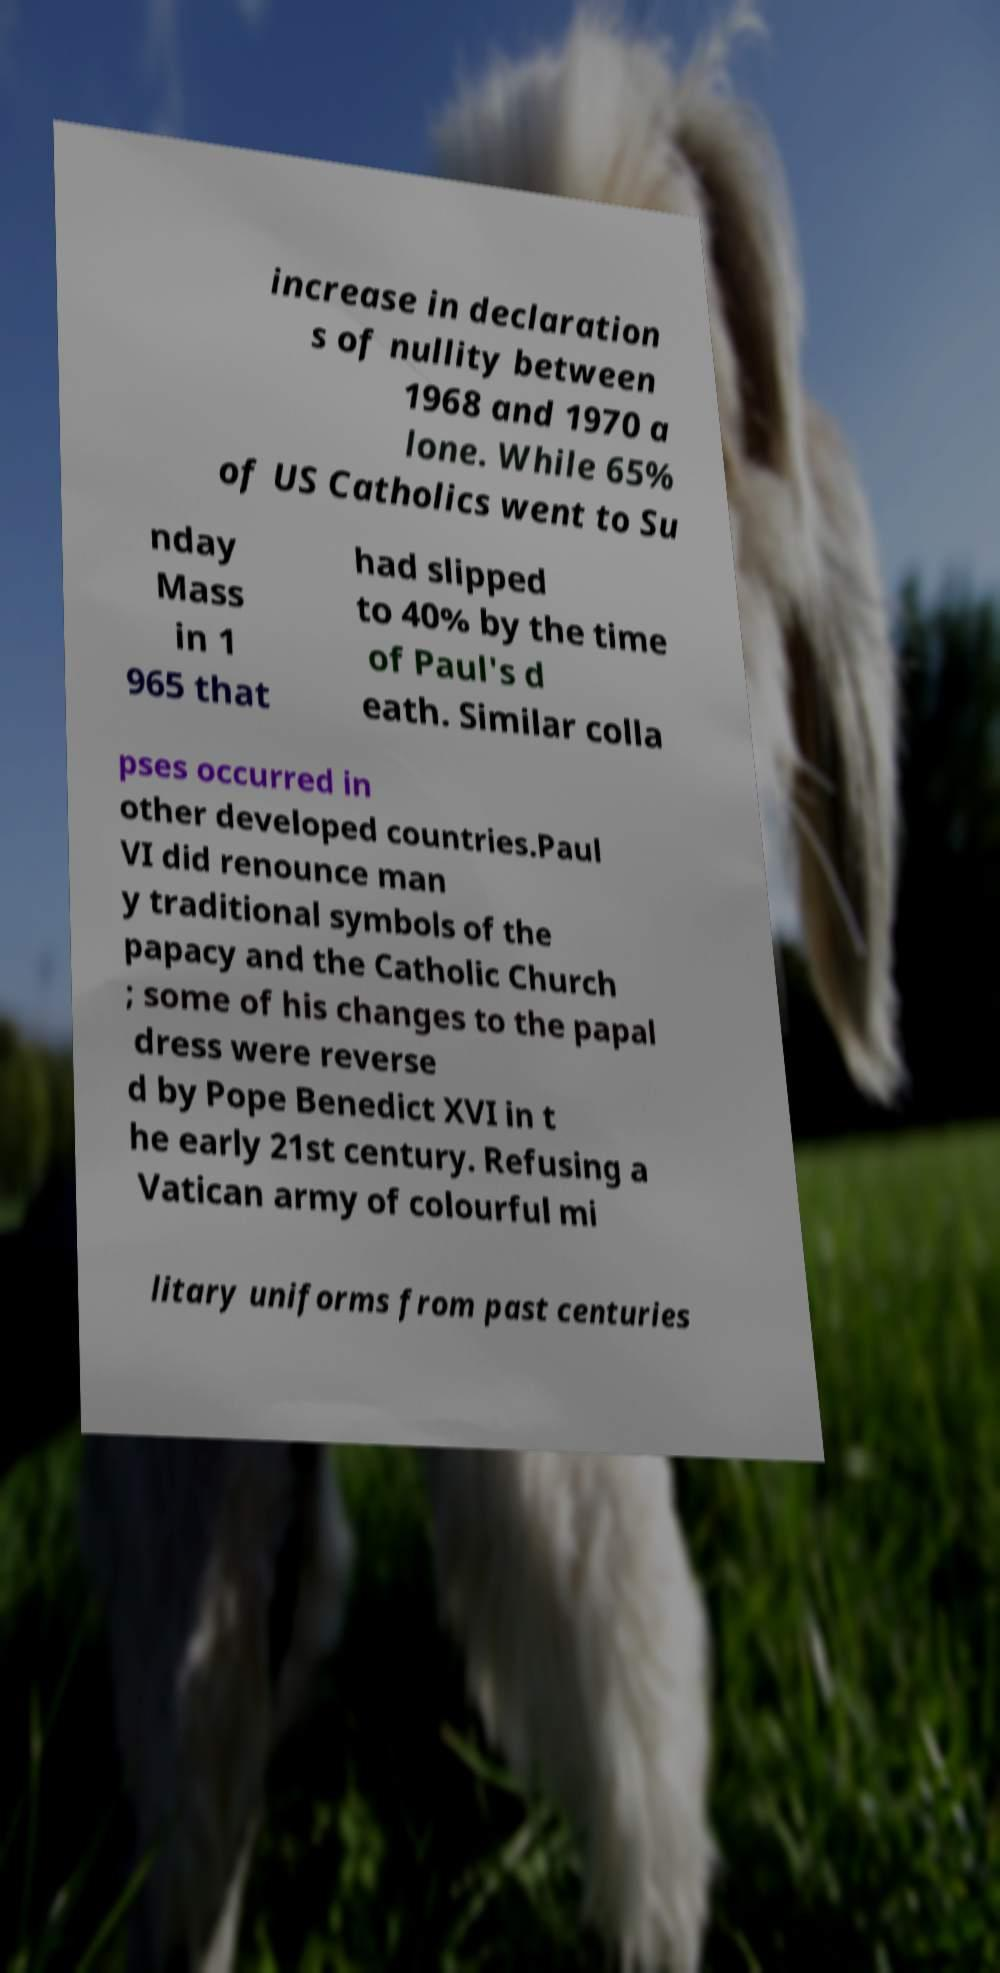Can you accurately transcribe the text from the provided image for me? increase in declaration s of nullity between 1968 and 1970 a lone. While 65% of US Catholics went to Su nday Mass in 1 965 that had slipped to 40% by the time of Paul's d eath. Similar colla pses occurred in other developed countries.Paul VI did renounce man y traditional symbols of the papacy and the Catholic Church ; some of his changes to the papal dress were reverse d by Pope Benedict XVI in t he early 21st century. Refusing a Vatican army of colourful mi litary uniforms from past centuries 